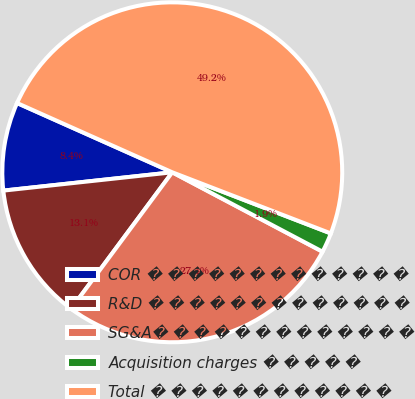Convert chart. <chart><loc_0><loc_0><loc_500><loc_500><pie_chart><fcel>COR � � � � � � � � � � � � �<fcel>R&D � � � � � � � � � � � � �<fcel>SG&A� � � � � � � � � � � � �<fcel>Acquisition charges � � � � �<fcel>Total � � � � � � � � � � � �<nl><fcel>8.4%<fcel>13.13%<fcel>27.42%<fcel>1.88%<fcel>49.18%<nl></chart> 